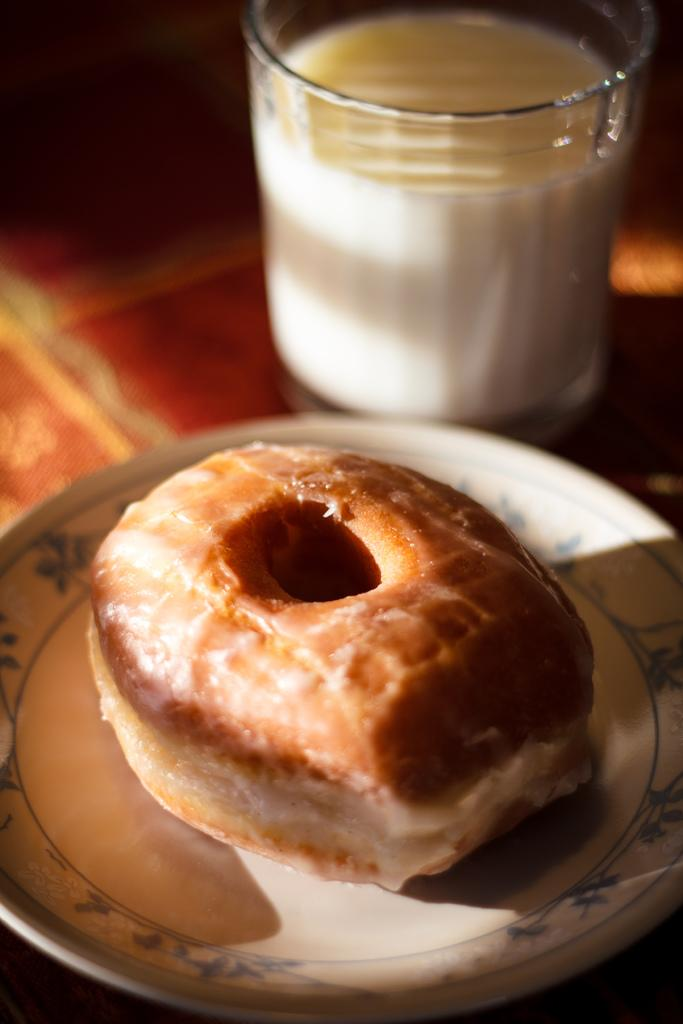What type of food item is on the plate in the image? There is a donut on a plate in the image. What is the other item visible in the image? There is a milk glass in the image. Where are the donut and milk glass located in the image? Both the donut and milk glass are on the floor in the image. What type of tramp is visible in the image? There is no tramp present in the image; it features a donut on a plate and a milk glass on the floor. What type of meal is being prepared in the image? There is no meal preparation visible in the image; it only shows a donut on a plate and a milk glass on the floor. 